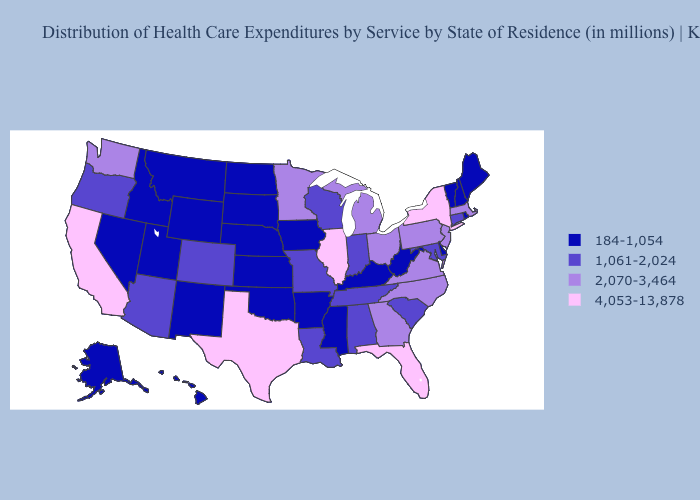What is the value of Utah?
Give a very brief answer. 184-1,054. Name the states that have a value in the range 184-1,054?
Write a very short answer. Alaska, Arkansas, Delaware, Hawaii, Idaho, Iowa, Kansas, Kentucky, Maine, Mississippi, Montana, Nebraska, Nevada, New Hampshire, New Mexico, North Dakota, Oklahoma, Rhode Island, South Dakota, Utah, Vermont, West Virginia, Wyoming. Does Vermont have the highest value in the USA?
Quick response, please. No. What is the highest value in states that border Tennessee?
Write a very short answer. 2,070-3,464. Does Minnesota have a lower value than Kansas?
Short answer required. No. Does Illinois have the same value as Texas?
Quick response, please. Yes. Which states have the lowest value in the Northeast?
Quick response, please. Maine, New Hampshire, Rhode Island, Vermont. Which states have the highest value in the USA?
Keep it brief. California, Florida, Illinois, New York, Texas. What is the highest value in the USA?
Keep it brief. 4,053-13,878. Among the states that border Massachusetts , does New York have the lowest value?
Give a very brief answer. No. What is the value of Pennsylvania?
Quick response, please. 2,070-3,464. Does Iowa have the lowest value in the MidWest?
Concise answer only. Yes. Name the states that have a value in the range 184-1,054?
Quick response, please. Alaska, Arkansas, Delaware, Hawaii, Idaho, Iowa, Kansas, Kentucky, Maine, Mississippi, Montana, Nebraska, Nevada, New Hampshire, New Mexico, North Dakota, Oklahoma, Rhode Island, South Dakota, Utah, Vermont, West Virginia, Wyoming. Name the states that have a value in the range 1,061-2,024?
Answer briefly. Alabama, Arizona, Colorado, Connecticut, Indiana, Louisiana, Maryland, Missouri, Oregon, South Carolina, Tennessee, Wisconsin. 